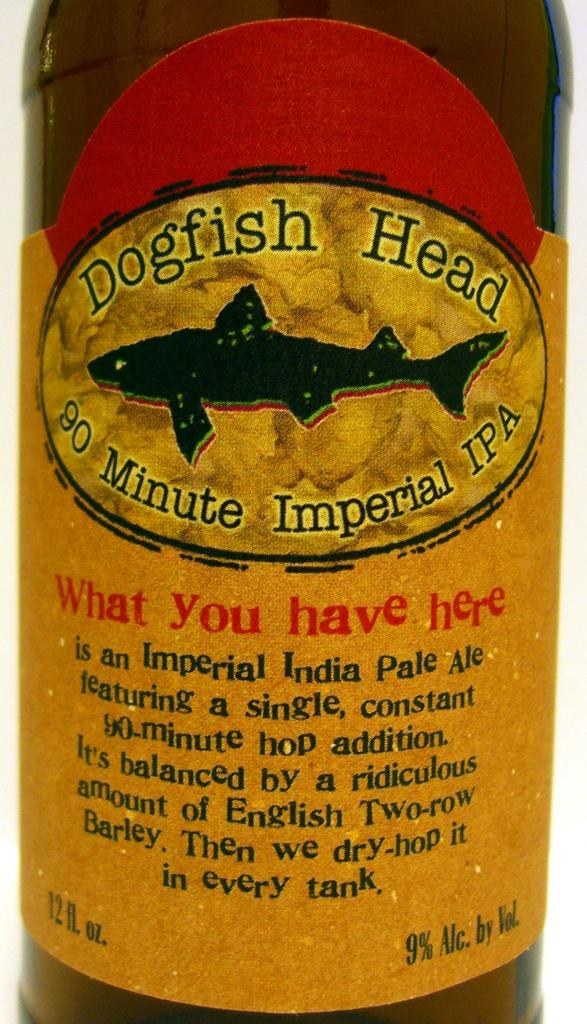What is on the object in the image? There is a sticker on an object in the image. What else can be seen on the object? There is writing on the object in the image. What does the mom say about the thunder in the image? There is no mention of a mom or thunder in the image; it only features a sticker and writing on an object. 